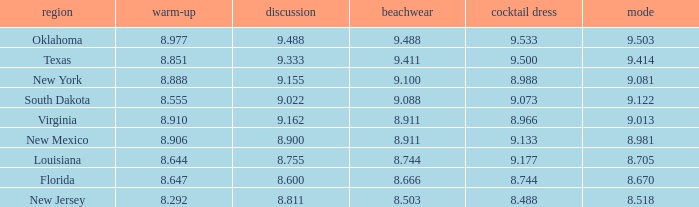What is the total number of average where evening gown is 8.988 1.0. 